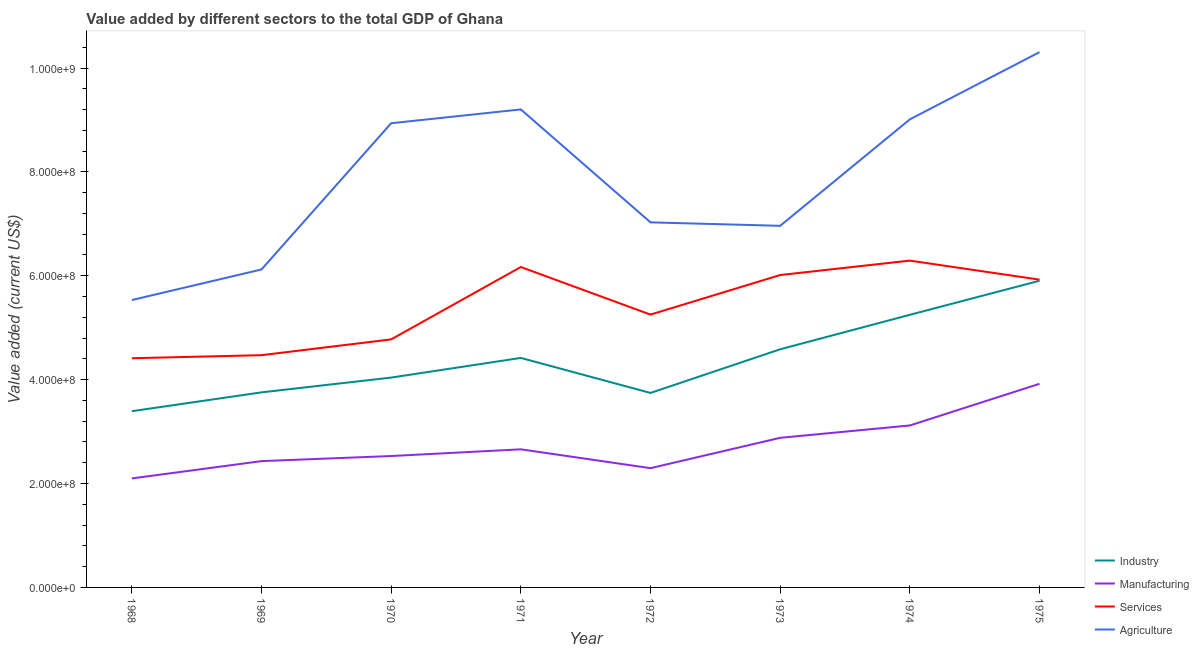How many different coloured lines are there?
Your answer should be compact. 4. Is the number of lines equal to the number of legend labels?
Give a very brief answer. Yes. What is the value added by agricultural sector in 1971?
Ensure brevity in your answer.  9.20e+08. Across all years, what is the maximum value added by agricultural sector?
Provide a short and direct response. 1.03e+09. Across all years, what is the minimum value added by manufacturing sector?
Give a very brief answer. 2.10e+08. In which year was the value added by services sector maximum?
Your answer should be compact. 1974. In which year was the value added by manufacturing sector minimum?
Give a very brief answer. 1968. What is the total value added by manufacturing sector in the graph?
Give a very brief answer. 2.19e+09. What is the difference between the value added by services sector in 1969 and that in 1972?
Offer a very short reply. -7.81e+07. What is the difference between the value added by agricultural sector in 1974 and the value added by industrial sector in 1970?
Provide a short and direct response. 4.97e+08. What is the average value added by manufacturing sector per year?
Provide a short and direct response. 2.74e+08. In the year 1971, what is the difference between the value added by services sector and value added by agricultural sector?
Your answer should be compact. -3.03e+08. What is the ratio of the value added by industrial sector in 1970 to that in 1974?
Your answer should be compact. 0.77. Is the value added by industrial sector in 1972 less than that in 1975?
Make the answer very short. Yes. Is the difference between the value added by industrial sector in 1968 and 1970 greater than the difference between the value added by manufacturing sector in 1968 and 1970?
Give a very brief answer. No. What is the difference between the highest and the second highest value added by services sector?
Ensure brevity in your answer.  1.23e+07. What is the difference between the highest and the lowest value added by manufacturing sector?
Provide a succinct answer. 1.82e+08. Is the value added by manufacturing sector strictly greater than the value added by services sector over the years?
Provide a succinct answer. No. How many lines are there?
Your answer should be very brief. 4. What is the difference between two consecutive major ticks on the Y-axis?
Your response must be concise. 2.00e+08. Does the graph contain grids?
Ensure brevity in your answer.  No. How are the legend labels stacked?
Keep it short and to the point. Vertical. What is the title of the graph?
Your answer should be compact. Value added by different sectors to the total GDP of Ghana. What is the label or title of the X-axis?
Your response must be concise. Year. What is the label or title of the Y-axis?
Offer a terse response. Value added (current US$). What is the Value added (current US$) of Industry in 1968?
Provide a succinct answer. 3.39e+08. What is the Value added (current US$) of Manufacturing in 1968?
Provide a succinct answer. 2.10e+08. What is the Value added (current US$) of Services in 1968?
Keep it short and to the point. 4.41e+08. What is the Value added (current US$) of Agriculture in 1968?
Offer a very short reply. 5.53e+08. What is the Value added (current US$) in Industry in 1969?
Provide a succinct answer. 3.76e+08. What is the Value added (current US$) of Manufacturing in 1969?
Offer a very short reply. 2.43e+08. What is the Value added (current US$) of Services in 1969?
Ensure brevity in your answer.  4.47e+08. What is the Value added (current US$) in Agriculture in 1969?
Provide a short and direct response. 6.12e+08. What is the Value added (current US$) in Industry in 1970?
Offer a very short reply. 4.04e+08. What is the Value added (current US$) in Manufacturing in 1970?
Ensure brevity in your answer.  2.53e+08. What is the Value added (current US$) of Services in 1970?
Your response must be concise. 4.78e+08. What is the Value added (current US$) in Agriculture in 1970?
Offer a very short reply. 8.94e+08. What is the Value added (current US$) of Industry in 1971?
Provide a short and direct response. 4.42e+08. What is the Value added (current US$) in Manufacturing in 1971?
Your answer should be very brief. 2.66e+08. What is the Value added (current US$) in Services in 1971?
Offer a very short reply. 6.17e+08. What is the Value added (current US$) in Agriculture in 1971?
Your answer should be very brief. 9.20e+08. What is the Value added (current US$) in Industry in 1972?
Your answer should be compact. 3.74e+08. What is the Value added (current US$) of Manufacturing in 1972?
Ensure brevity in your answer.  2.30e+08. What is the Value added (current US$) in Services in 1972?
Your answer should be very brief. 5.25e+08. What is the Value added (current US$) in Agriculture in 1972?
Make the answer very short. 7.03e+08. What is the Value added (current US$) of Industry in 1973?
Your response must be concise. 4.58e+08. What is the Value added (current US$) in Manufacturing in 1973?
Make the answer very short. 2.88e+08. What is the Value added (current US$) of Services in 1973?
Provide a succinct answer. 6.01e+08. What is the Value added (current US$) in Agriculture in 1973?
Your answer should be compact. 6.96e+08. What is the Value added (current US$) in Industry in 1974?
Give a very brief answer. 5.25e+08. What is the Value added (current US$) of Manufacturing in 1974?
Keep it short and to the point. 3.12e+08. What is the Value added (current US$) of Services in 1974?
Make the answer very short. 6.29e+08. What is the Value added (current US$) in Agriculture in 1974?
Offer a very short reply. 9.01e+08. What is the Value added (current US$) of Industry in 1975?
Make the answer very short. 5.90e+08. What is the Value added (current US$) of Manufacturing in 1975?
Offer a terse response. 3.92e+08. What is the Value added (current US$) of Services in 1975?
Make the answer very short. 5.93e+08. What is the Value added (current US$) in Agriculture in 1975?
Give a very brief answer. 1.03e+09. Across all years, what is the maximum Value added (current US$) in Industry?
Your answer should be very brief. 5.90e+08. Across all years, what is the maximum Value added (current US$) of Manufacturing?
Your answer should be compact. 3.92e+08. Across all years, what is the maximum Value added (current US$) of Services?
Ensure brevity in your answer.  6.29e+08. Across all years, what is the maximum Value added (current US$) in Agriculture?
Offer a very short reply. 1.03e+09. Across all years, what is the minimum Value added (current US$) in Industry?
Your response must be concise. 3.39e+08. Across all years, what is the minimum Value added (current US$) in Manufacturing?
Offer a very short reply. 2.10e+08. Across all years, what is the minimum Value added (current US$) of Services?
Your answer should be compact. 4.41e+08. Across all years, what is the minimum Value added (current US$) of Agriculture?
Offer a very short reply. 5.53e+08. What is the total Value added (current US$) of Industry in the graph?
Your answer should be compact. 3.51e+09. What is the total Value added (current US$) in Manufacturing in the graph?
Provide a succinct answer. 2.19e+09. What is the total Value added (current US$) of Services in the graph?
Provide a succinct answer. 4.33e+09. What is the total Value added (current US$) in Agriculture in the graph?
Provide a short and direct response. 6.31e+09. What is the difference between the Value added (current US$) in Industry in 1968 and that in 1969?
Your answer should be very brief. -3.63e+07. What is the difference between the Value added (current US$) in Manufacturing in 1968 and that in 1969?
Provide a succinct answer. -3.33e+07. What is the difference between the Value added (current US$) of Services in 1968 and that in 1969?
Offer a very short reply. -5.88e+06. What is the difference between the Value added (current US$) of Agriculture in 1968 and that in 1969?
Offer a terse response. -5.88e+07. What is the difference between the Value added (current US$) of Industry in 1968 and that in 1970?
Provide a short and direct response. -6.47e+07. What is the difference between the Value added (current US$) of Manufacturing in 1968 and that in 1970?
Offer a terse response. -4.31e+07. What is the difference between the Value added (current US$) in Services in 1968 and that in 1970?
Offer a very short reply. -3.63e+07. What is the difference between the Value added (current US$) in Agriculture in 1968 and that in 1970?
Your answer should be compact. -3.40e+08. What is the difference between the Value added (current US$) in Industry in 1968 and that in 1971?
Ensure brevity in your answer.  -1.03e+08. What is the difference between the Value added (current US$) of Manufacturing in 1968 and that in 1971?
Ensure brevity in your answer.  -5.60e+07. What is the difference between the Value added (current US$) of Services in 1968 and that in 1971?
Ensure brevity in your answer.  -1.76e+08. What is the difference between the Value added (current US$) in Agriculture in 1968 and that in 1971?
Provide a short and direct response. -3.67e+08. What is the difference between the Value added (current US$) of Industry in 1968 and that in 1972?
Your response must be concise. -3.52e+07. What is the difference between the Value added (current US$) in Manufacturing in 1968 and that in 1972?
Give a very brief answer. -1.98e+07. What is the difference between the Value added (current US$) in Services in 1968 and that in 1972?
Keep it short and to the point. -8.40e+07. What is the difference between the Value added (current US$) of Agriculture in 1968 and that in 1972?
Offer a terse response. -1.50e+08. What is the difference between the Value added (current US$) in Industry in 1968 and that in 1973?
Offer a very short reply. -1.19e+08. What is the difference between the Value added (current US$) of Manufacturing in 1968 and that in 1973?
Offer a very short reply. -7.82e+07. What is the difference between the Value added (current US$) of Services in 1968 and that in 1973?
Your response must be concise. -1.60e+08. What is the difference between the Value added (current US$) of Agriculture in 1968 and that in 1973?
Your answer should be compact. -1.43e+08. What is the difference between the Value added (current US$) of Industry in 1968 and that in 1974?
Offer a very short reply. -1.86e+08. What is the difference between the Value added (current US$) in Manufacturing in 1968 and that in 1974?
Offer a terse response. -1.02e+08. What is the difference between the Value added (current US$) of Services in 1968 and that in 1974?
Provide a short and direct response. -1.88e+08. What is the difference between the Value added (current US$) in Agriculture in 1968 and that in 1974?
Ensure brevity in your answer.  -3.48e+08. What is the difference between the Value added (current US$) of Industry in 1968 and that in 1975?
Keep it short and to the point. -2.51e+08. What is the difference between the Value added (current US$) in Manufacturing in 1968 and that in 1975?
Your answer should be compact. -1.82e+08. What is the difference between the Value added (current US$) in Services in 1968 and that in 1975?
Give a very brief answer. -1.51e+08. What is the difference between the Value added (current US$) of Agriculture in 1968 and that in 1975?
Ensure brevity in your answer.  -4.77e+08. What is the difference between the Value added (current US$) in Industry in 1969 and that in 1970?
Provide a short and direct response. -2.84e+07. What is the difference between the Value added (current US$) of Manufacturing in 1969 and that in 1970?
Keep it short and to the point. -9.81e+06. What is the difference between the Value added (current US$) of Services in 1969 and that in 1970?
Your response must be concise. -3.04e+07. What is the difference between the Value added (current US$) in Agriculture in 1969 and that in 1970?
Keep it short and to the point. -2.82e+08. What is the difference between the Value added (current US$) of Industry in 1969 and that in 1971?
Provide a succinct answer. -6.63e+07. What is the difference between the Value added (current US$) of Manufacturing in 1969 and that in 1971?
Make the answer very short. -2.27e+07. What is the difference between the Value added (current US$) in Services in 1969 and that in 1971?
Your answer should be very brief. -1.70e+08. What is the difference between the Value added (current US$) of Agriculture in 1969 and that in 1971?
Offer a terse response. -3.08e+08. What is the difference between the Value added (current US$) of Industry in 1969 and that in 1972?
Offer a very short reply. 1.11e+06. What is the difference between the Value added (current US$) in Manufacturing in 1969 and that in 1972?
Provide a short and direct response. 1.36e+07. What is the difference between the Value added (current US$) in Services in 1969 and that in 1972?
Keep it short and to the point. -7.81e+07. What is the difference between the Value added (current US$) in Agriculture in 1969 and that in 1972?
Provide a succinct answer. -9.07e+07. What is the difference between the Value added (current US$) of Industry in 1969 and that in 1973?
Offer a terse response. -8.29e+07. What is the difference between the Value added (current US$) in Manufacturing in 1969 and that in 1973?
Ensure brevity in your answer.  -4.49e+07. What is the difference between the Value added (current US$) in Services in 1969 and that in 1973?
Offer a terse response. -1.54e+08. What is the difference between the Value added (current US$) of Agriculture in 1969 and that in 1973?
Provide a succinct answer. -8.41e+07. What is the difference between the Value added (current US$) in Industry in 1969 and that in 1974?
Your answer should be compact. -1.49e+08. What is the difference between the Value added (current US$) in Manufacturing in 1969 and that in 1974?
Offer a very short reply. -6.86e+07. What is the difference between the Value added (current US$) in Services in 1969 and that in 1974?
Your answer should be compact. -1.82e+08. What is the difference between the Value added (current US$) of Agriculture in 1969 and that in 1974?
Your answer should be very brief. -2.89e+08. What is the difference between the Value added (current US$) in Industry in 1969 and that in 1975?
Your answer should be compact. -2.15e+08. What is the difference between the Value added (current US$) of Manufacturing in 1969 and that in 1975?
Provide a succinct answer. -1.49e+08. What is the difference between the Value added (current US$) of Services in 1969 and that in 1975?
Offer a terse response. -1.45e+08. What is the difference between the Value added (current US$) of Agriculture in 1969 and that in 1975?
Your response must be concise. -4.18e+08. What is the difference between the Value added (current US$) of Industry in 1970 and that in 1971?
Your answer should be compact. -3.79e+07. What is the difference between the Value added (current US$) of Manufacturing in 1970 and that in 1971?
Offer a very short reply. -1.29e+07. What is the difference between the Value added (current US$) of Services in 1970 and that in 1971?
Your answer should be very brief. -1.39e+08. What is the difference between the Value added (current US$) in Agriculture in 1970 and that in 1971?
Offer a very short reply. -2.66e+07. What is the difference between the Value added (current US$) in Industry in 1970 and that in 1972?
Offer a very short reply. 2.95e+07. What is the difference between the Value added (current US$) in Manufacturing in 1970 and that in 1972?
Make the answer very short. 2.34e+07. What is the difference between the Value added (current US$) of Services in 1970 and that in 1972?
Give a very brief answer. -4.77e+07. What is the difference between the Value added (current US$) of Agriculture in 1970 and that in 1972?
Provide a short and direct response. 1.91e+08. What is the difference between the Value added (current US$) of Industry in 1970 and that in 1973?
Give a very brief answer. -5.45e+07. What is the difference between the Value added (current US$) of Manufacturing in 1970 and that in 1973?
Your response must be concise. -3.51e+07. What is the difference between the Value added (current US$) in Services in 1970 and that in 1973?
Ensure brevity in your answer.  -1.24e+08. What is the difference between the Value added (current US$) of Agriculture in 1970 and that in 1973?
Your answer should be very brief. 1.97e+08. What is the difference between the Value added (current US$) in Industry in 1970 and that in 1974?
Your answer should be very brief. -1.21e+08. What is the difference between the Value added (current US$) in Manufacturing in 1970 and that in 1974?
Your answer should be compact. -5.88e+07. What is the difference between the Value added (current US$) of Services in 1970 and that in 1974?
Offer a terse response. -1.52e+08. What is the difference between the Value added (current US$) in Agriculture in 1970 and that in 1974?
Keep it short and to the point. -7.45e+06. What is the difference between the Value added (current US$) in Industry in 1970 and that in 1975?
Your answer should be very brief. -1.86e+08. What is the difference between the Value added (current US$) in Manufacturing in 1970 and that in 1975?
Your answer should be very brief. -1.39e+08. What is the difference between the Value added (current US$) in Services in 1970 and that in 1975?
Keep it short and to the point. -1.15e+08. What is the difference between the Value added (current US$) in Agriculture in 1970 and that in 1975?
Offer a terse response. -1.37e+08. What is the difference between the Value added (current US$) in Industry in 1971 and that in 1972?
Keep it short and to the point. 6.74e+07. What is the difference between the Value added (current US$) in Manufacturing in 1971 and that in 1972?
Ensure brevity in your answer.  3.63e+07. What is the difference between the Value added (current US$) in Services in 1971 and that in 1972?
Give a very brief answer. 9.16e+07. What is the difference between the Value added (current US$) of Agriculture in 1971 and that in 1972?
Offer a terse response. 2.17e+08. What is the difference between the Value added (current US$) in Industry in 1971 and that in 1973?
Your response must be concise. -1.66e+07. What is the difference between the Value added (current US$) of Manufacturing in 1971 and that in 1973?
Offer a terse response. -2.21e+07. What is the difference between the Value added (current US$) in Services in 1971 and that in 1973?
Your answer should be very brief. 1.54e+07. What is the difference between the Value added (current US$) of Agriculture in 1971 and that in 1973?
Provide a short and direct response. 2.24e+08. What is the difference between the Value added (current US$) of Industry in 1971 and that in 1974?
Offer a terse response. -8.30e+07. What is the difference between the Value added (current US$) in Manufacturing in 1971 and that in 1974?
Give a very brief answer. -4.59e+07. What is the difference between the Value added (current US$) of Services in 1971 and that in 1974?
Your response must be concise. -1.23e+07. What is the difference between the Value added (current US$) of Agriculture in 1971 and that in 1974?
Your answer should be very brief. 1.92e+07. What is the difference between the Value added (current US$) of Industry in 1971 and that in 1975?
Offer a very short reply. -1.49e+08. What is the difference between the Value added (current US$) in Manufacturing in 1971 and that in 1975?
Provide a short and direct response. -1.26e+08. What is the difference between the Value added (current US$) in Services in 1971 and that in 1975?
Provide a short and direct response. 2.43e+07. What is the difference between the Value added (current US$) in Agriculture in 1971 and that in 1975?
Provide a short and direct response. -1.10e+08. What is the difference between the Value added (current US$) in Industry in 1972 and that in 1973?
Your answer should be compact. -8.40e+07. What is the difference between the Value added (current US$) in Manufacturing in 1972 and that in 1973?
Your answer should be compact. -5.84e+07. What is the difference between the Value added (current US$) in Services in 1972 and that in 1973?
Your answer should be compact. -7.61e+07. What is the difference between the Value added (current US$) in Agriculture in 1972 and that in 1973?
Offer a terse response. 6.64e+06. What is the difference between the Value added (current US$) of Industry in 1972 and that in 1974?
Your answer should be very brief. -1.50e+08. What is the difference between the Value added (current US$) of Manufacturing in 1972 and that in 1974?
Your response must be concise. -8.22e+07. What is the difference between the Value added (current US$) of Services in 1972 and that in 1974?
Keep it short and to the point. -1.04e+08. What is the difference between the Value added (current US$) in Agriculture in 1972 and that in 1974?
Keep it short and to the point. -1.98e+08. What is the difference between the Value added (current US$) in Industry in 1972 and that in 1975?
Keep it short and to the point. -2.16e+08. What is the difference between the Value added (current US$) of Manufacturing in 1972 and that in 1975?
Give a very brief answer. -1.62e+08. What is the difference between the Value added (current US$) of Services in 1972 and that in 1975?
Your answer should be compact. -6.73e+07. What is the difference between the Value added (current US$) in Agriculture in 1972 and that in 1975?
Offer a very short reply. -3.28e+08. What is the difference between the Value added (current US$) in Industry in 1973 and that in 1974?
Your response must be concise. -6.64e+07. What is the difference between the Value added (current US$) in Manufacturing in 1973 and that in 1974?
Give a very brief answer. -2.38e+07. What is the difference between the Value added (current US$) of Services in 1973 and that in 1974?
Offer a very short reply. -2.78e+07. What is the difference between the Value added (current US$) of Agriculture in 1973 and that in 1974?
Provide a succinct answer. -2.05e+08. What is the difference between the Value added (current US$) of Industry in 1973 and that in 1975?
Your answer should be very brief. -1.32e+08. What is the difference between the Value added (current US$) in Manufacturing in 1973 and that in 1975?
Give a very brief answer. -1.04e+08. What is the difference between the Value added (current US$) in Services in 1973 and that in 1975?
Offer a very short reply. 8.86e+06. What is the difference between the Value added (current US$) in Agriculture in 1973 and that in 1975?
Provide a succinct answer. -3.34e+08. What is the difference between the Value added (current US$) of Industry in 1974 and that in 1975?
Provide a short and direct response. -6.56e+07. What is the difference between the Value added (current US$) in Manufacturing in 1974 and that in 1975?
Your response must be concise. -8.02e+07. What is the difference between the Value added (current US$) in Services in 1974 and that in 1975?
Keep it short and to the point. 3.66e+07. What is the difference between the Value added (current US$) in Agriculture in 1974 and that in 1975?
Your response must be concise. -1.29e+08. What is the difference between the Value added (current US$) in Industry in 1968 and the Value added (current US$) in Manufacturing in 1969?
Make the answer very short. 9.61e+07. What is the difference between the Value added (current US$) in Industry in 1968 and the Value added (current US$) in Services in 1969?
Your answer should be compact. -1.08e+08. What is the difference between the Value added (current US$) of Industry in 1968 and the Value added (current US$) of Agriculture in 1969?
Give a very brief answer. -2.73e+08. What is the difference between the Value added (current US$) of Manufacturing in 1968 and the Value added (current US$) of Services in 1969?
Provide a short and direct response. -2.37e+08. What is the difference between the Value added (current US$) of Manufacturing in 1968 and the Value added (current US$) of Agriculture in 1969?
Provide a succinct answer. -4.02e+08. What is the difference between the Value added (current US$) in Services in 1968 and the Value added (current US$) in Agriculture in 1969?
Your answer should be very brief. -1.71e+08. What is the difference between the Value added (current US$) of Industry in 1968 and the Value added (current US$) of Manufacturing in 1970?
Keep it short and to the point. 8.63e+07. What is the difference between the Value added (current US$) in Industry in 1968 and the Value added (current US$) in Services in 1970?
Your answer should be compact. -1.38e+08. What is the difference between the Value added (current US$) in Industry in 1968 and the Value added (current US$) in Agriculture in 1970?
Make the answer very short. -5.54e+08. What is the difference between the Value added (current US$) in Manufacturing in 1968 and the Value added (current US$) in Services in 1970?
Your answer should be very brief. -2.68e+08. What is the difference between the Value added (current US$) of Manufacturing in 1968 and the Value added (current US$) of Agriculture in 1970?
Give a very brief answer. -6.84e+08. What is the difference between the Value added (current US$) in Services in 1968 and the Value added (current US$) in Agriculture in 1970?
Give a very brief answer. -4.52e+08. What is the difference between the Value added (current US$) of Industry in 1968 and the Value added (current US$) of Manufacturing in 1971?
Your answer should be compact. 7.34e+07. What is the difference between the Value added (current US$) in Industry in 1968 and the Value added (current US$) in Services in 1971?
Give a very brief answer. -2.78e+08. What is the difference between the Value added (current US$) of Industry in 1968 and the Value added (current US$) of Agriculture in 1971?
Provide a succinct answer. -5.81e+08. What is the difference between the Value added (current US$) in Manufacturing in 1968 and the Value added (current US$) in Services in 1971?
Your answer should be very brief. -4.07e+08. What is the difference between the Value added (current US$) of Manufacturing in 1968 and the Value added (current US$) of Agriculture in 1971?
Your answer should be very brief. -7.10e+08. What is the difference between the Value added (current US$) of Services in 1968 and the Value added (current US$) of Agriculture in 1971?
Offer a terse response. -4.79e+08. What is the difference between the Value added (current US$) in Industry in 1968 and the Value added (current US$) in Manufacturing in 1972?
Ensure brevity in your answer.  1.10e+08. What is the difference between the Value added (current US$) of Industry in 1968 and the Value added (current US$) of Services in 1972?
Your answer should be compact. -1.86e+08. What is the difference between the Value added (current US$) in Industry in 1968 and the Value added (current US$) in Agriculture in 1972?
Keep it short and to the point. -3.64e+08. What is the difference between the Value added (current US$) in Manufacturing in 1968 and the Value added (current US$) in Services in 1972?
Your answer should be very brief. -3.15e+08. What is the difference between the Value added (current US$) of Manufacturing in 1968 and the Value added (current US$) of Agriculture in 1972?
Your response must be concise. -4.93e+08. What is the difference between the Value added (current US$) of Services in 1968 and the Value added (current US$) of Agriculture in 1972?
Offer a terse response. -2.62e+08. What is the difference between the Value added (current US$) of Industry in 1968 and the Value added (current US$) of Manufacturing in 1973?
Offer a very short reply. 5.12e+07. What is the difference between the Value added (current US$) in Industry in 1968 and the Value added (current US$) in Services in 1973?
Provide a short and direct response. -2.62e+08. What is the difference between the Value added (current US$) in Industry in 1968 and the Value added (current US$) in Agriculture in 1973?
Offer a very short reply. -3.57e+08. What is the difference between the Value added (current US$) of Manufacturing in 1968 and the Value added (current US$) of Services in 1973?
Your answer should be very brief. -3.92e+08. What is the difference between the Value added (current US$) in Manufacturing in 1968 and the Value added (current US$) in Agriculture in 1973?
Make the answer very short. -4.86e+08. What is the difference between the Value added (current US$) of Services in 1968 and the Value added (current US$) of Agriculture in 1973?
Keep it short and to the point. -2.55e+08. What is the difference between the Value added (current US$) in Industry in 1968 and the Value added (current US$) in Manufacturing in 1974?
Provide a short and direct response. 2.75e+07. What is the difference between the Value added (current US$) of Industry in 1968 and the Value added (current US$) of Services in 1974?
Make the answer very short. -2.90e+08. What is the difference between the Value added (current US$) in Industry in 1968 and the Value added (current US$) in Agriculture in 1974?
Offer a very short reply. -5.62e+08. What is the difference between the Value added (current US$) of Manufacturing in 1968 and the Value added (current US$) of Services in 1974?
Ensure brevity in your answer.  -4.19e+08. What is the difference between the Value added (current US$) of Manufacturing in 1968 and the Value added (current US$) of Agriculture in 1974?
Offer a terse response. -6.91e+08. What is the difference between the Value added (current US$) of Services in 1968 and the Value added (current US$) of Agriculture in 1974?
Give a very brief answer. -4.60e+08. What is the difference between the Value added (current US$) in Industry in 1968 and the Value added (current US$) in Manufacturing in 1975?
Give a very brief answer. -5.28e+07. What is the difference between the Value added (current US$) of Industry in 1968 and the Value added (current US$) of Services in 1975?
Provide a short and direct response. -2.53e+08. What is the difference between the Value added (current US$) of Industry in 1968 and the Value added (current US$) of Agriculture in 1975?
Make the answer very short. -6.91e+08. What is the difference between the Value added (current US$) in Manufacturing in 1968 and the Value added (current US$) in Services in 1975?
Your answer should be compact. -3.83e+08. What is the difference between the Value added (current US$) of Manufacturing in 1968 and the Value added (current US$) of Agriculture in 1975?
Give a very brief answer. -8.21e+08. What is the difference between the Value added (current US$) of Services in 1968 and the Value added (current US$) of Agriculture in 1975?
Give a very brief answer. -5.89e+08. What is the difference between the Value added (current US$) in Industry in 1969 and the Value added (current US$) in Manufacturing in 1970?
Your response must be concise. 1.23e+08. What is the difference between the Value added (current US$) of Industry in 1969 and the Value added (current US$) of Services in 1970?
Provide a succinct answer. -1.02e+08. What is the difference between the Value added (current US$) in Industry in 1969 and the Value added (current US$) in Agriculture in 1970?
Provide a succinct answer. -5.18e+08. What is the difference between the Value added (current US$) in Manufacturing in 1969 and the Value added (current US$) in Services in 1970?
Provide a succinct answer. -2.34e+08. What is the difference between the Value added (current US$) of Manufacturing in 1969 and the Value added (current US$) of Agriculture in 1970?
Make the answer very short. -6.50e+08. What is the difference between the Value added (current US$) in Services in 1969 and the Value added (current US$) in Agriculture in 1970?
Your answer should be compact. -4.47e+08. What is the difference between the Value added (current US$) in Industry in 1969 and the Value added (current US$) in Manufacturing in 1971?
Provide a succinct answer. 1.10e+08. What is the difference between the Value added (current US$) of Industry in 1969 and the Value added (current US$) of Services in 1971?
Offer a terse response. -2.41e+08. What is the difference between the Value added (current US$) in Industry in 1969 and the Value added (current US$) in Agriculture in 1971?
Give a very brief answer. -5.45e+08. What is the difference between the Value added (current US$) of Manufacturing in 1969 and the Value added (current US$) of Services in 1971?
Provide a succinct answer. -3.74e+08. What is the difference between the Value added (current US$) of Manufacturing in 1969 and the Value added (current US$) of Agriculture in 1971?
Provide a succinct answer. -6.77e+08. What is the difference between the Value added (current US$) in Services in 1969 and the Value added (current US$) in Agriculture in 1971?
Offer a terse response. -4.73e+08. What is the difference between the Value added (current US$) of Industry in 1969 and the Value added (current US$) of Manufacturing in 1972?
Your answer should be very brief. 1.46e+08. What is the difference between the Value added (current US$) of Industry in 1969 and the Value added (current US$) of Services in 1972?
Provide a short and direct response. -1.50e+08. What is the difference between the Value added (current US$) of Industry in 1969 and the Value added (current US$) of Agriculture in 1972?
Your response must be concise. -3.27e+08. What is the difference between the Value added (current US$) of Manufacturing in 1969 and the Value added (current US$) of Services in 1972?
Offer a very short reply. -2.82e+08. What is the difference between the Value added (current US$) of Manufacturing in 1969 and the Value added (current US$) of Agriculture in 1972?
Your response must be concise. -4.60e+08. What is the difference between the Value added (current US$) of Services in 1969 and the Value added (current US$) of Agriculture in 1972?
Offer a very short reply. -2.56e+08. What is the difference between the Value added (current US$) of Industry in 1969 and the Value added (current US$) of Manufacturing in 1973?
Ensure brevity in your answer.  8.75e+07. What is the difference between the Value added (current US$) of Industry in 1969 and the Value added (current US$) of Services in 1973?
Make the answer very short. -2.26e+08. What is the difference between the Value added (current US$) of Industry in 1969 and the Value added (current US$) of Agriculture in 1973?
Your answer should be very brief. -3.21e+08. What is the difference between the Value added (current US$) in Manufacturing in 1969 and the Value added (current US$) in Services in 1973?
Offer a very short reply. -3.58e+08. What is the difference between the Value added (current US$) of Manufacturing in 1969 and the Value added (current US$) of Agriculture in 1973?
Your answer should be compact. -4.53e+08. What is the difference between the Value added (current US$) in Services in 1969 and the Value added (current US$) in Agriculture in 1973?
Offer a very short reply. -2.49e+08. What is the difference between the Value added (current US$) of Industry in 1969 and the Value added (current US$) of Manufacturing in 1974?
Offer a very short reply. 6.37e+07. What is the difference between the Value added (current US$) in Industry in 1969 and the Value added (current US$) in Services in 1974?
Your response must be concise. -2.54e+08. What is the difference between the Value added (current US$) in Industry in 1969 and the Value added (current US$) in Agriculture in 1974?
Make the answer very short. -5.26e+08. What is the difference between the Value added (current US$) in Manufacturing in 1969 and the Value added (current US$) in Services in 1974?
Offer a very short reply. -3.86e+08. What is the difference between the Value added (current US$) of Manufacturing in 1969 and the Value added (current US$) of Agriculture in 1974?
Give a very brief answer. -6.58e+08. What is the difference between the Value added (current US$) in Services in 1969 and the Value added (current US$) in Agriculture in 1974?
Offer a terse response. -4.54e+08. What is the difference between the Value added (current US$) in Industry in 1969 and the Value added (current US$) in Manufacturing in 1975?
Keep it short and to the point. -1.65e+07. What is the difference between the Value added (current US$) of Industry in 1969 and the Value added (current US$) of Services in 1975?
Your answer should be compact. -2.17e+08. What is the difference between the Value added (current US$) in Industry in 1969 and the Value added (current US$) in Agriculture in 1975?
Provide a succinct answer. -6.55e+08. What is the difference between the Value added (current US$) in Manufacturing in 1969 and the Value added (current US$) in Services in 1975?
Offer a terse response. -3.49e+08. What is the difference between the Value added (current US$) in Manufacturing in 1969 and the Value added (current US$) in Agriculture in 1975?
Provide a short and direct response. -7.87e+08. What is the difference between the Value added (current US$) of Services in 1969 and the Value added (current US$) of Agriculture in 1975?
Keep it short and to the point. -5.83e+08. What is the difference between the Value added (current US$) in Industry in 1970 and the Value added (current US$) in Manufacturing in 1971?
Provide a short and direct response. 1.38e+08. What is the difference between the Value added (current US$) of Industry in 1970 and the Value added (current US$) of Services in 1971?
Your answer should be very brief. -2.13e+08. What is the difference between the Value added (current US$) of Industry in 1970 and the Value added (current US$) of Agriculture in 1971?
Your answer should be very brief. -5.16e+08. What is the difference between the Value added (current US$) of Manufacturing in 1970 and the Value added (current US$) of Services in 1971?
Make the answer very short. -3.64e+08. What is the difference between the Value added (current US$) of Manufacturing in 1970 and the Value added (current US$) of Agriculture in 1971?
Provide a short and direct response. -6.67e+08. What is the difference between the Value added (current US$) in Services in 1970 and the Value added (current US$) in Agriculture in 1971?
Ensure brevity in your answer.  -4.43e+08. What is the difference between the Value added (current US$) in Industry in 1970 and the Value added (current US$) in Manufacturing in 1972?
Your response must be concise. 1.74e+08. What is the difference between the Value added (current US$) in Industry in 1970 and the Value added (current US$) in Services in 1972?
Keep it short and to the point. -1.21e+08. What is the difference between the Value added (current US$) in Industry in 1970 and the Value added (current US$) in Agriculture in 1972?
Provide a succinct answer. -2.99e+08. What is the difference between the Value added (current US$) in Manufacturing in 1970 and the Value added (current US$) in Services in 1972?
Provide a succinct answer. -2.72e+08. What is the difference between the Value added (current US$) of Manufacturing in 1970 and the Value added (current US$) of Agriculture in 1972?
Give a very brief answer. -4.50e+08. What is the difference between the Value added (current US$) in Services in 1970 and the Value added (current US$) in Agriculture in 1972?
Ensure brevity in your answer.  -2.25e+08. What is the difference between the Value added (current US$) in Industry in 1970 and the Value added (current US$) in Manufacturing in 1973?
Give a very brief answer. 1.16e+08. What is the difference between the Value added (current US$) in Industry in 1970 and the Value added (current US$) in Services in 1973?
Offer a terse response. -1.97e+08. What is the difference between the Value added (current US$) of Industry in 1970 and the Value added (current US$) of Agriculture in 1973?
Keep it short and to the point. -2.92e+08. What is the difference between the Value added (current US$) of Manufacturing in 1970 and the Value added (current US$) of Services in 1973?
Your response must be concise. -3.48e+08. What is the difference between the Value added (current US$) of Manufacturing in 1970 and the Value added (current US$) of Agriculture in 1973?
Give a very brief answer. -4.43e+08. What is the difference between the Value added (current US$) of Services in 1970 and the Value added (current US$) of Agriculture in 1973?
Offer a very short reply. -2.19e+08. What is the difference between the Value added (current US$) in Industry in 1970 and the Value added (current US$) in Manufacturing in 1974?
Give a very brief answer. 9.22e+07. What is the difference between the Value added (current US$) of Industry in 1970 and the Value added (current US$) of Services in 1974?
Your answer should be very brief. -2.25e+08. What is the difference between the Value added (current US$) of Industry in 1970 and the Value added (current US$) of Agriculture in 1974?
Keep it short and to the point. -4.97e+08. What is the difference between the Value added (current US$) of Manufacturing in 1970 and the Value added (current US$) of Services in 1974?
Give a very brief answer. -3.76e+08. What is the difference between the Value added (current US$) in Manufacturing in 1970 and the Value added (current US$) in Agriculture in 1974?
Provide a short and direct response. -6.48e+08. What is the difference between the Value added (current US$) in Services in 1970 and the Value added (current US$) in Agriculture in 1974?
Your response must be concise. -4.24e+08. What is the difference between the Value added (current US$) of Industry in 1970 and the Value added (current US$) of Manufacturing in 1975?
Your response must be concise. 1.20e+07. What is the difference between the Value added (current US$) in Industry in 1970 and the Value added (current US$) in Services in 1975?
Keep it short and to the point. -1.89e+08. What is the difference between the Value added (current US$) in Industry in 1970 and the Value added (current US$) in Agriculture in 1975?
Your response must be concise. -6.27e+08. What is the difference between the Value added (current US$) of Manufacturing in 1970 and the Value added (current US$) of Services in 1975?
Your answer should be compact. -3.40e+08. What is the difference between the Value added (current US$) of Manufacturing in 1970 and the Value added (current US$) of Agriculture in 1975?
Offer a terse response. -7.78e+08. What is the difference between the Value added (current US$) of Services in 1970 and the Value added (current US$) of Agriculture in 1975?
Give a very brief answer. -5.53e+08. What is the difference between the Value added (current US$) of Industry in 1971 and the Value added (current US$) of Manufacturing in 1972?
Your response must be concise. 2.12e+08. What is the difference between the Value added (current US$) of Industry in 1971 and the Value added (current US$) of Services in 1972?
Provide a short and direct response. -8.34e+07. What is the difference between the Value added (current US$) of Industry in 1971 and the Value added (current US$) of Agriculture in 1972?
Ensure brevity in your answer.  -2.61e+08. What is the difference between the Value added (current US$) in Manufacturing in 1971 and the Value added (current US$) in Services in 1972?
Keep it short and to the point. -2.59e+08. What is the difference between the Value added (current US$) in Manufacturing in 1971 and the Value added (current US$) in Agriculture in 1972?
Provide a short and direct response. -4.37e+08. What is the difference between the Value added (current US$) of Services in 1971 and the Value added (current US$) of Agriculture in 1972?
Your answer should be very brief. -8.60e+07. What is the difference between the Value added (current US$) in Industry in 1971 and the Value added (current US$) in Manufacturing in 1973?
Your answer should be very brief. 1.54e+08. What is the difference between the Value added (current US$) in Industry in 1971 and the Value added (current US$) in Services in 1973?
Make the answer very short. -1.60e+08. What is the difference between the Value added (current US$) in Industry in 1971 and the Value added (current US$) in Agriculture in 1973?
Your answer should be very brief. -2.54e+08. What is the difference between the Value added (current US$) of Manufacturing in 1971 and the Value added (current US$) of Services in 1973?
Make the answer very short. -3.36e+08. What is the difference between the Value added (current US$) in Manufacturing in 1971 and the Value added (current US$) in Agriculture in 1973?
Provide a succinct answer. -4.30e+08. What is the difference between the Value added (current US$) of Services in 1971 and the Value added (current US$) of Agriculture in 1973?
Give a very brief answer. -7.93e+07. What is the difference between the Value added (current US$) of Industry in 1971 and the Value added (current US$) of Manufacturing in 1974?
Your answer should be compact. 1.30e+08. What is the difference between the Value added (current US$) in Industry in 1971 and the Value added (current US$) in Services in 1974?
Your response must be concise. -1.87e+08. What is the difference between the Value added (current US$) in Industry in 1971 and the Value added (current US$) in Agriculture in 1974?
Provide a short and direct response. -4.59e+08. What is the difference between the Value added (current US$) in Manufacturing in 1971 and the Value added (current US$) in Services in 1974?
Your answer should be compact. -3.63e+08. What is the difference between the Value added (current US$) of Manufacturing in 1971 and the Value added (current US$) of Agriculture in 1974?
Your response must be concise. -6.35e+08. What is the difference between the Value added (current US$) of Services in 1971 and the Value added (current US$) of Agriculture in 1974?
Keep it short and to the point. -2.84e+08. What is the difference between the Value added (current US$) in Industry in 1971 and the Value added (current US$) in Manufacturing in 1975?
Make the answer very short. 4.98e+07. What is the difference between the Value added (current US$) of Industry in 1971 and the Value added (current US$) of Services in 1975?
Ensure brevity in your answer.  -1.51e+08. What is the difference between the Value added (current US$) of Industry in 1971 and the Value added (current US$) of Agriculture in 1975?
Make the answer very short. -5.89e+08. What is the difference between the Value added (current US$) in Manufacturing in 1971 and the Value added (current US$) in Services in 1975?
Provide a succinct answer. -3.27e+08. What is the difference between the Value added (current US$) of Manufacturing in 1971 and the Value added (current US$) of Agriculture in 1975?
Your response must be concise. -7.65e+08. What is the difference between the Value added (current US$) of Services in 1971 and the Value added (current US$) of Agriculture in 1975?
Provide a succinct answer. -4.14e+08. What is the difference between the Value added (current US$) in Industry in 1972 and the Value added (current US$) in Manufacturing in 1973?
Ensure brevity in your answer.  8.64e+07. What is the difference between the Value added (current US$) in Industry in 1972 and the Value added (current US$) in Services in 1973?
Provide a short and direct response. -2.27e+08. What is the difference between the Value added (current US$) of Industry in 1972 and the Value added (current US$) of Agriculture in 1973?
Your answer should be compact. -3.22e+08. What is the difference between the Value added (current US$) of Manufacturing in 1972 and the Value added (current US$) of Services in 1973?
Offer a terse response. -3.72e+08. What is the difference between the Value added (current US$) of Manufacturing in 1972 and the Value added (current US$) of Agriculture in 1973?
Offer a terse response. -4.67e+08. What is the difference between the Value added (current US$) of Services in 1972 and the Value added (current US$) of Agriculture in 1973?
Provide a short and direct response. -1.71e+08. What is the difference between the Value added (current US$) of Industry in 1972 and the Value added (current US$) of Manufacturing in 1974?
Make the answer very short. 6.26e+07. What is the difference between the Value added (current US$) of Industry in 1972 and the Value added (current US$) of Services in 1974?
Provide a short and direct response. -2.55e+08. What is the difference between the Value added (current US$) in Industry in 1972 and the Value added (current US$) in Agriculture in 1974?
Your answer should be compact. -5.27e+08. What is the difference between the Value added (current US$) in Manufacturing in 1972 and the Value added (current US$) in Services in 1974?
Give a very brief answer. -4.00e+08. What is the difference between the Value added (current US$) in Manufacturing in 1972 and the Value added (current US$) in Agriculture in 1974?
Your answer should be compact. -6.71e+08. What is the difference between the Value added (current US$) of Services in 1972 and the Value added (current US$) of Agriculture in 1974?
Ensure brevity in your answer.  -3.76e+08. What is the difference between the Value added (current US$) in Industry in 1972 and the Value added (current US$) in Manufacturing in 1975?
Keep it short and to the point. -1.76e+07. What is the difference between the Value added (current US$) in Industry in 1972 and the Value added (current US$) in Services in 1975?
Offer a very short reply. -2.18e+08. What is the difference between the Value added (current US$) of Industry in 1972 and the Value added (current US$) of Agriculture in 1975?
Provide a succinct answer. -6.56e+08. What is the difference between the Value added (current US$) in Manufacturing in 1972 and the Value added (current US$) in Services in 1975?
Offer a terse response. -3.63e+08. What is the difference between the Value added (current US$) of Manufacturing in 1972 and the Value added (current US$) of Agriculture in 1975?
Provide a succinct answer. -8.01e+08. What is the difference between the Value added (current US$) in Services in 1972 and the Value added (current US$) in Agriculture in 1975?
Ensure brevity in your answer.  -5.05e+08. What is the difference between the Value added (current US$) of Industry in 1973 and the Value added (current US$) of Manufacturing in 1974?
Offer a terse response. 1.47e+08. What is the difference between the Value added (current US$) of Industry in 1973 and the Value added (current US$) of Services in 1974?
Make the answer very short. -1.71e+08. What is the difference between the Value added (current US$) of Industry in 1973 and the Value added (current US$) of Agriculture in 1974?
Provide a succinct answer. -4.43e+08. What is the difference between the Value added (current US$) of Manufacturing in 1973 and the Value added (current US$) of Services in 1974?
Provide a succinct answer. -3.41e+08. What is the difference between the Value added (current US$) in Manufacturing in 1973 and the Value added (current US$) in Agriculture in 1974?
Offer a terse response. -6.13e+08. What is the difference between the Value added (current US$) of Services in 1973 and the Value added (current US$) of Agriculture in 1974?
Offer a terse response. -3.00e+08. What is the difference between the Value added (current US$) in Industry in 1973 and the Value added (current US$) in Manufacturing in 1975?
Offer a very short reply. 6.64e+07. What is the difference between the Value added (current US$) of Industry in 1973 and the Value added (current US$) of Services in 1975?
Give a very brief answer. -1.34e+08. What is the difference between the Value added (current US$) of Industry in 1973 and the Value added (current US$) of Agriculture in 1975?
Offer a very short reply. -5.72e+08. What is the difference between the Value added (current US$) in Manufacturing in 1973 and the Value added (current US$) in Services in 1975?
Offer a very short reply. -3.05e+08. What is the difference between the Value added (current US$) in Manufacturing in 1973 and the Value added (current US$) in Agriculture in 1975?
Offer a very short reply. -7.43e+08. What is the difference between the Value added (current US$) of Services in 1973 and the Value added (current US$) of Agriculture in 1975?
Offer a very short reply. -4.29e+08. What is the difference between the Value added (current US$) in Industry in 1974 and the Value added (current US$) in Manufacturing in 1975?
Ensure brevity in your answer.  1.33e+08. What is the difference between the Value added (current US$) of Industry in 1974 and the Value added (current US$) of Services in 1975?
Provide a succinct answer. -6.77e+07. What is the difference between the Value added (current US$) in Industry in 1974 and the Value added (current US$) in Agriculture in 1975?
Keep it short and to the point. -5.06e+08. What is the difference between the Value added (current US$) in Manufacturing in 1974 and the Value added (current US$) in Services in 1975?
Your answer should be compact. -2.81e+08. What is the difference between the Value added (current US$) of Manufacturing in 1974 and the Value added (current US$) of Agriculture in 1975?
Provide a short and direct response. -7.19e+08. What is the difference between the Value added (current US$) of Services in 1974 and the Value added (current US$) of Agriculture in 1975?
Ensure brevity in your answer.  -4.01e+08. What is the average Value added (current US$) of Industry per year?
Your answer should be compact. 4.39e+08. What is the average Value added (current US$) in Manufacturing per year?
Give a very brief answer. 2.74e+08. What is the average Value added (current US$) in Services per year?
Ensure brevity in your answer.  5.41e+08. What is the average Value added (current US$) of Agriculture per year?
Ensure brevity in your answer.  7.89e+08. In the year 1968, what is the difference between the Value added (current US$) in Industry and Value added (current US$) in Manufacturing?
Keep it short and to the point. 1.29e+08. In the year 1968, what is the difference between the Value added (current US$) of Industry and Value added (current US$) of Services?
Give a very brief answer. -1.02e+08. In the year 1968, what is the difference between the Value added (current US$) in Industry and Value added (current US$) in Agriculture?
Provide a short and direct response. -2.14e+08. In the year 1968, what is the difference between the Value added (current US$) in Manufacturing and Value added (current US$) in Services?
Give a very brief answer. -2.31e+08. In the year 1968, what is the difference between the Value added (current US$) of Manufacturing and Value added (current US$) of Agriculture?
Keep it short and to the point. -3.43e+08. In the year 1968, what is the difference between the Value added (current US$) of Services and Value added (current US$) of Agriculture?
Provide a short and direct response. -1.12e+08. In the year 1969, what is the difference between the Value added (current US$) of Industry and Value added (current US$) of Manufacturing?
Your response must be concise. 1.32e+08. In the year 1969, what is the difference between the Value added (current US$) in Industry and Value added (current US$) in Services?
Your response must be concise. -7.16e+07. In the year 1969, what is the difference between the Value added (current US$) of Industry and Value added (current US$) of Agriculture?
Make the answer very short. -2.37e+08. In the year 1969, what is the difference between the Value added (current US$) in Manufacturing and Value added (current US$) in Services?
Give a very brief answer. -2.04e+08. In the year 1969, what is the difference between the Value added (current US$) in Manufacturing and Value added (current US$) in Agriculture?
Ensure brevity in your answer.  -3.69e+08. In the year 1969, what is the difference between the Value added (current US$) of Services and Value added (current US$) of Agriculture?
Provide a short and direct response. -1.65e+08. In the year 1970, what is the difference between the Value added (current US$) in Industry and Value added (current US$) in Manufacturing?
Your answer should be compact. 1.51e+08. In the year 1970, what is the difference between the Value added (current US$) of Industry and Value added (current US$) of Services?
Keep it short and to the point. -7.35e+07. In the year 1970, what is the difference between the Value added (current US$) in Industry and Value added (current US$) in Agriculture?
Make the answer very short. -4.90e+08. In the year 1970, what is the difference between the Value added (current US$) of Manufacturing and Value added (current US$) of Services?
Ensure brevity in your answer.  -2.25e+08. In the year 1970, what is the difference between the Value added (current US$) in Manufacturing and Value added (current US$) in Agriculture?
Your answer should be very brief. -6.41e+08. In the year 1970, what is the difference between the Value added (current US$) in Services and Value added (current US$) in Agriculture?
Keep it short and to the point. -4.16e+08. In the year 1971, what is the difference between the Value added (current US$) of Industry and Value added (current US$) of Manufacturing?
Your response must be concise. 1.76e+08. In the year 1971, what is the difference between the Value added (current US$) in Industry and Value added (current US$) in Services?
Provide a short and direct response. -1.75e+08. In the year 1971, what is the difference between the Value added (current US$) in Industry and Value added (current US$) in Agriculture?
Offer a terse response. -4.78e+08. In the year 1971, what is the difference between the Value added (current US$) in Manufacturing and Value added (current US$) in Services?
Your response must be concise. -3.51e+08. In the year 1971, what is the difference between the Value added (current US$) of Manufacturing and Value added (current US$) of Agriculture?
Offer a terse response. -6.54e+08. In the year 1971, what is the difference between the Value added (current US$) of Services and Value added (current US$) of Agriculture?
Your response must be concise. -3.03e+08. In the year 1972, what is the difference between the Value added (current US$) of Industry and Value added (current US$) of Manufacturing?
Offer a very short reply. 1.45e+08. In the year 1972, what is the difference between the Value added (current US$) of Industry and Value added (current US$) of Services?
Make the answer very short. -1.51e+08. In the year 1972, what is the difference between the Value added (current US$) in Industry and Value added (current US$) in Agriculture?
Offer a terse response. -3.28e+08. In the year 1972, what is the difference between the Value added (current US$) in Manufacturing and Value added (current US$) in Services?
Your response must be concise. -2.96e+08. In the year 1972, what is the difference between the Value added (current US$) of Manufacturing and Value added (current US$) of Agriculture?
Make the answer very short. -4.73e+08. In the year 1972, what is the difference between the Value added (current US$) of Services and Value added (current US$) of Agriculture?
Make the answer very short. -1.78e+08. In the year 1973, what is the difference between the Value added (current US$) in Industry and Value added (current US$) in Manufacturing?
Offer a terse response. 1.70e+08. In the year 1973, what is the difference between the Value added (current US$) in Industry and Value added (current US$) in Services?
Your response must be concise. -1.43e+08. In the year 1973, what is the difference between the Value added (current US$) of Industry and Value added (current US$) of Agriculture?
Offer a terse response. -2.38e+08. In the year 1973, what is the difference between the Value added (current US$) of Manufacturing and Value added (current US$) of Services?
Offer a terse response. -3.13e+08. In the year 1973, what is the difference between the Value added (current US$) of Manufacturing and Value added (current US$) of Agriculture?
Offer a terse response. -4.08e+08. In the year 1973, what is the difference between the Value added (current US$) of Services and Value added (current US$) of Agriculture?
Your answer should be compact. -9.48e+07. In the year 1974, what is the difference between the Value added (current US$) in Industry and Value added (current US$) in Manufacturing?
Your answer should be very brief. 2.13e+08. In the year 1974, what is the difference between the Value added (current US$) in Industry and Value added (current US$) in Services?
Provide a succinct answer. -1.04e+08. In the year 1974, what is the difference between the Value added (current US$) of Industry and Value added (current US$) of Agriculture?
Give a very brief answer. -3.76e+08. In the year 1974, what is the difference between the Value added (current US$) of Manufacturing and Value added (current US$) of Services?
Give a very brief answer. -3.17e+08. In the year 1974, what is the difference between the Value added (current US$) in Manufacturing and Value added (current US$) in Agriculture?
Your answer should be very brief. -5.89e+08. In the year 1974, what is the difference between the Value added (current US$) of Services and Value added (current US$) of Agriculture?
Give a very brief answer. -2.72e+08. In the year 1975, what is the difference between the Value added (current US$) of Industry and Value added (current US$) of Manufacturing?
Offer a very short reply. 1.98e+08. In the year 1975, what is the difference between the Value added (current US$) of Industry and Value added (current US$) of Services?
Give a very brief answer. -2.13e+06. In the year 1975, what is the difference between the Value added (current US$) in Industry and Value added (current US$) in Agriculture?
Keep it short and to the point. -4.40e+08. In the year 1975, what is the difference between the Value added (current US$) in Manufacturing and Value added (current US$) in Services?
Ensure brevity in your answer.  -2.01e+08. In the year 1975, what is the difference between the Value added (current US$) of Manufacturing and Value added (current US$) of Agriculture?
Keep it short and to the point. -6.39e+08. In the year 1975, what is the difference between the Value added (current US$) in Services and Value added (current US$) in Agriculture?
Provide a short and direct response. -4.38e+08. What is the ratio of the Value added (current US$) of Industry in 1968 to that in 1969?
Provide a short and direct response. 0.9. What is the ratio of the Value added (current US$) of Manufacturing in 1968 to that in 1969?
Provide a succinct answer. 0.86. What is the ratio of the Value added (current US$) of Agriculture in 1968 to that in 1969?
Keep it short and to the point. 0.9. What is the ratio of the Value added (current US$) of Industry in 1968 to that in 1970?
Provide a succinct answer. 0.84. What is the ratio of the Value added (current US$) of Manufacturing in 1968 to that in 1970?
Offer a terse response. 0.83. What is the ratio of the Value added (current US$) of Services in 1968 to that in 1970?
Provide a succinct answer. 0.92. What is the ratio of the Value added (current US$) in Agriculture in 1968 to that in 1970?
Keep it short and to the point. 0.62. What is the ratio of the Value added (current US$) in Industry in 1968 to that in 1971?
Make the answer very short. 0.77. What is the ratio of the Value added (current US$) of Manufacturing in 1968 to that in 1971?
Offer a very short reply. 0.79. What is the ratio of the Value added (current US$) of Services in 1968 to that in 1971?
Give a very brief answer. 0.72. What is the ratio of the Value added (current US$) of Agriculture in 1968 to that in 1971?
Keep it short and to the point. 0.6. What is the ratio of the Value added (current US$) in Industry in 1968 to that in 1972?
Offer a terse response. 0.91. What is the ratio of the Value added (current US$) in Manufacturing in 1968 to that in 1972?
Provide a succinct answer. 0.91. What is the ratio of the Value added (current US$) in Services in 1968 to that in 1972?
Offer a very short reply. 0.84. What is the ratio of the Value added (current US$) in Agriculture in 1968 to that in 1972?
Ensure brevity in your answer.  0.79. What is the ratio of the Value added (current US$) in Industry in 1968 to that in 1973?
Provide a succinct answer. 0.74. What is the ratio of the Value added (current US$) of Manufacturing in 1968 to that in 1973?
Your response must be concise. 0.73. What is the ratio of the Value added (current US$) in Services in 1968 to that in 1973?
Your answer should be compact. 0.73. What is the ratio of the Value added (current US$) in Agriculture in 1968 to that in 1973?
Your answer should be compact. 0.79. What is the ratio of the Value added (current US$) in Industry in 1968 to that in 1974?
Your answer should be very brief. 0.65. What is the ratio of the Value added (current US$) of Manufacturing in 1968 to that in 1974?
Your answer should be compact. 0.67. What is the ratio of the Value added (current US$) in Services in 1968 to that in 1974?
Your answer should be very brief. 0.7. What is the ratio of the Value added (current US$) of Agriculture in 1968 to that in 1974?
Your answer should be very brief. 0.61. What is the ratio of the Value added (current US$) in Industry in 1968 to that in 1975?
Keep it short and to the point. 0.57. What is the ratio of the Value added (current US$) of Manufacturing in 1968 to that in 1975?
Offer a very short reply. 0.54. What is the ratio of the Value added (current US$) in Services in 1968 to that in 1975?
Your answer should be very brief. 0.74. What is the ratio of the Value added (current US$) in Agriculture in 1968 to that in 1975?
Provide a short and direct response. 0.54. What is the ratio of the Value added (current US$) in Industry in 1969 to that in 1970?
Your answer should be compact. 0.93. What is the ratio of the Value added (current US$) in Manufacturing in 1969 to that in 1970?
Your answer should be very brief. 0.96. What is the ratio of the Value added (current US$) in Services in 1969 to that in 1970?
Your answer should be compact. 0.94. What is the ratio of the Value added (current US$) of Agriculture in 1969 to that in 1970?
Make the answer very short. 0.69. What is the ratio of the Value added (current US$) of Industry in 1969 to that in 1971?
Keep it short and to the point. 0.85. What is the ratio of the Value added (current US$) in Manufacturing in 1969 to that in 1971?
Keep it short and to the point. 0.91. What is the ratio of the Value added (current US$) in Services in 1969 to that in 1971?
Provide a short and direct response. 0.72. What is the ratio of the Value added (current US$) of Agriculture in 1969 to that in 1971?
Give a very brief answer. 0.67. What is the ratio of the Value added (current US$) of Industry in 1969 to that in 1972?
Give a very brief answer. 1. What is the ratio of the Value added (current US$) in Manufacturing in 1969 to that in 1972?
Offer a terse response. 1.06. What is the ratio of the Value added (current US$) in Services in 1969 to that in 1972?
Your answer should be compact. 0.85. What is the ratio of the Value added (current US$) of Agriculture in 1969 to that in 1972?
Ensure brevity in your answer.  0.87. What is the ratio of the Value added (current US$) in Industry in 1969 to that in 1973?
Your answer should be very brief. 0.82. What is the ratio of the Value added (current US$) of Manufacturing in 1969 to that in 1973?
Offer a very short reply. 0.84. What is the ratio of the Value added (current US$) of Services in 1969 to that in 1973?
Offer a very short reply. 0.74. What is the ratio of the Value added (current US$) in Agriculture in 1969 to that in 1973?
Your answer should be very brief. 0.88. What is the ratio of the Value added (current US$) in Industry in 1969 to that in 1974?
Offer a terse response. 0.72. What is the ratio of the Value added (current US$) in Manufacturing in 1969 to that in 1974?
Ensure brevity in your answer.  0.78. What is the ratio of the Value added (current US$) of Services in 1969 to that in 1974?
Keep it short and to the point. 0.71. What is the ratio of the Value added (current US$) of Agriculture in 1969 to that in 1974?
Offer a very short reply. 0.68. What is the ratio of the Value added (current US$) of Industry in 1969 to that in 1975?
Give a very brief answer. 0.64. What is the ratio of the Value added (current US$) of Manufacturing in 1969 to that in 1975?
Your answer should be compact. 0.62. What is the ratio of the Value added (current US$) in Services in 1969 to that in 1975?
Offer a terse response. 0.75. What is the ratio of the Value added (current US$) in Agriculture in 1969 to that in 1975?
Provide a short and direct response. 0.59. What is the ratio of the Value added (current US$) of Industry in 1970 to that in 1971?
Your answer should be very brief. 0.91. What is the ratio of the Value added (current US$) in Manufacturing in 1970 to that in 1971?
Your answer should be very brief. 0.95. What is the ratio of the Value added (current US$) of Services in 1970 to that in 1971?
Your response must be concise. 0.77. What is the ratio of the Value added (current US$) of Agriculture in 1970 to that in 1971?
Make the answer very short. 0.97. What is the ratio of the Value added (current US$) in Industry in 1970 to that in 1972?
Offer a terse response. 1.08. What is the ratio of the Value added (current US$) in Manufacturing in 1970 to that in 1972?
Offer a terse response. 1.1. What is the ratio of the Value added (current US$) in Agriculture in 1970 to that in 1972?
Keep it short and to the point. 1.27. What is the ratio of the Value added (current US$) of Industry in 1970 to that in 1973?
Your answer should be very brief. 0.88. What is the ratio of the Value added (current US$) in Manufacturing in 1970 to that in 1973?
Provide a short and direct response. 0.88. What is the ratio of the Value added (current US$) of Services in 1970 to that in 1973?
Your answer should be compact. 0.79. What is the ratio of the Value added (current US$) in Agriculture in 1970 to that in 1973?
Keep it short and to the point. 1.28. What is the ratio of the Value added (current US$) of Industry in 1970 to that in 1974?
Keep it short and to the point. 0.77. What is the ratio of the Value added (current US$) in Manufacturing in 1970 to that in 1974?
Provide a succinct answer. 0.81. What is the ratio of the Value added (current US$) in Services in 1970 to that in 1974?
Provide a short and direct response. 0.76. What is the ratio of the Value added (current US$) in Agriculture in 1970 to that in 1974?
Your answer should be very brief. 0.99. What is the ratio of the Value added (current US$) in Industry in 1970 to that in 1975?
Offer a terse response. 0.68. What is the ratio of the Value added (current US$) in Manufacturing in 1970 to that in 1975?
Make the answer very short. 0.65. What is the ratio of the Value added (current US$) of Services in 1970 to that in 1975?
Your response must be concise. 0.81. What is the ratio of the Value added (current US$) of Agriculture in 1970 to that in 1975?
Provide a succinct answer. 0.87. What is the ratio of the Value added (current US$) in Industry in 1971 to that in 1972?
Give a very brief answer. 1.18. What is the ratio of the Value added (current US$) of Manufacturing in 1971 to that in 1972?
Offer a terse response. 1.16. What is the ratio of the Value added (current US$) of Services in 1971 to that in 1972?
Ensure brevity in your answer.  1.17. What is the ratio of the Value added (current US$) of Agriculture in 1971 to that in 1972?
Make the answer very short. 1.31. What is the ratio of the Value added (current US$) in Industry in 1971 to that in 1973?
Keep it short and to the point. 0.96. What is the ratio of the Value added (current US$) in Manufacturing in 1971 to that in 1973?
Provide a short and direct response. 0.92. What is the ratio of the Value added (current US$) in Services in 1971 to that in 1973?
Your answer should be very brief. 1.03. What is the ratio of the Value added (current US$) of Agriculture in 1971 to that in 1973?
Provide a short and direct response. 1.32. What is the ratio of the Value added (current US$) of Industry in 1971 to that in 1974?
Your answer should be very brief. 0.84. What is the ratio of the Value added (current US$) in Manufacturing in 1971 to that in 1974?
Offer a terse response. 0.85. What is the ratio of the Value added (current US$) in Services in 1971 to that in 1974?
Provide a short and direct response. 0.98. What is the ratio of the Value added (current US$) in Agriculture in 1971 to that in 1974?
Your answer should be very brief. 1.02. What is the ratio of the Value added (current US$) of Industry in 1971 to that in 1975?
Provide a short and direct response. 0.75. What is the ratio of the Value added (current US$) of Manufacturing in 1971 to that in 1975?
Offer a very short reply. 0.68. What is the ratio of the Value added (current US$) in Services in 1971 to that in 1975?
Give a very brief answer. 1.04. What is the ratio of the Value added (current US$) in Agriculture in 1971 to that in 1975?
Offer a very short reply. 0.89. What is the ratio of the Value added (current US$) of Industry in 1972 to that in 1973?
Ensure brevity in your answer.  0.82. What is the ratio of the Value added (current US$) in Manufacturing in 1972 to that in 1973?
Your answer should be compact. 0.8. What is the ratio of the Value added (current US$) in Services in 1972 to that in 1973?
Offer a terse response. 0.87. What is the ratio of the Value added (current US$) in Agriculture in 1972 to that in 1973?
Ensure brevity in your answer.  1.01. What is the ratio of the Value added (current US$) of Industry in 1972 to that in 1974?
Offer a very short reply. 0.71. What is the ratio of the Value added (current US$) in Manufacturing in 1972 to that in 1974?
Your answer should be very brief. 0.74. What is the ratio of the Value added (current US$) in Services in 1972 to that in 1974?
Give a very brief answer. 0.83. What is the ratio of the Value added (current US$) in Agriculture in 1972 to that in 1974?
Keep it short and to the point. 0.78. What is the ratio of the Value added (current US$) of Industry in 1972 to that in 1975?
Your answer should be compact. 0.63. What is the ratio of the Value added (current US$) in Manufacturing in 1972 to that in 1975?
Make the answer very short. 0.59. What is the ratio of the Value added (current US$) of Services in 1972 to that in 1975?
Provide a succinct answer. 0.89. What is the ratio of the Value added (current US$) in Agriculture in 1972 to that in 1975?
Keep it short and to the point. 0.68. What is the ratio of the Value added (current US$) of Industry in 1973 to that in 1974?
Keep it short and to the point. 0.87. What is the ratio of the Value added (current US$) in Manufacturing in 1973 to that in 1974?
Offer a terse response. 0.92. What is the ratio of the Value added (current US$) in Services in 1973 to that in 1974?
Make the answer very short. 0.96. What is the ratio of the Value added (current US$) in Agriculture in 1973 to that in 1974?
Your response must be concise. 0.77. What is the ratio of the Value added (current US$) of Industry in 1973 to that in 1975?
Your answer should be compact. 0.78. What is the ratio of the Value added (current US$) in Manufacturing in 1973 to that in 1975?
Make the answer very short. 0.73. What is the ratio of the Value added (current US$) of Services in 1973 to that in 1975?
Your answer should be very brief. 1.01. What is the ratio of the Value added (current US$) in Agriculture in 1973 to that in 1975?
Your answer should be compact. 0.68. What is the ratio of the Value added (current US$) in Manufacturing in 1974 to that in 1975?
Keep it short and to the point. 0.8. What is the ratio of the Value added (current US$) of Services in 1974 to that in 1975?
Offer a very short reply. 1.06. What is the ratio of the Value added (current US$) in Agriculture in 1974 to that in 1975?
Provide a succinct answer. 0.87. What is the difference between the highest and the second highest Value added (current US$) of Industry?
Provide a short and direct response. 6.56e+07. What is the difference between the highest and the second highest Value added (current US$) of Manufacturing?
Your answer should be compact. 8.02e+07. What is the difference between the highest and the second highest Value added (current US$) in Services?
Your answer should be compact. 1.23e+07. What is the difference between the highest and the second highest Value added (current US$) of Agriculture?
Make the answer very short. 1.10e+08. What is the difference between the highest and the lowest Value added (current US$) in Industry?
Make the answer very short. 2.51e+08. What is the difference between the highest and the lowest Value added (current US$) in Manufacturing?
Provide a short and direct response. 1.82e+08. What is the difference between the highest and the lowest Value added (current US$) of Services?
Your answer should be very brief. 1.88e+08. What is the difference between the highest and the lowest Value added (current US$) of Agriculture?
Offer a terse response. 4.77e+08. 